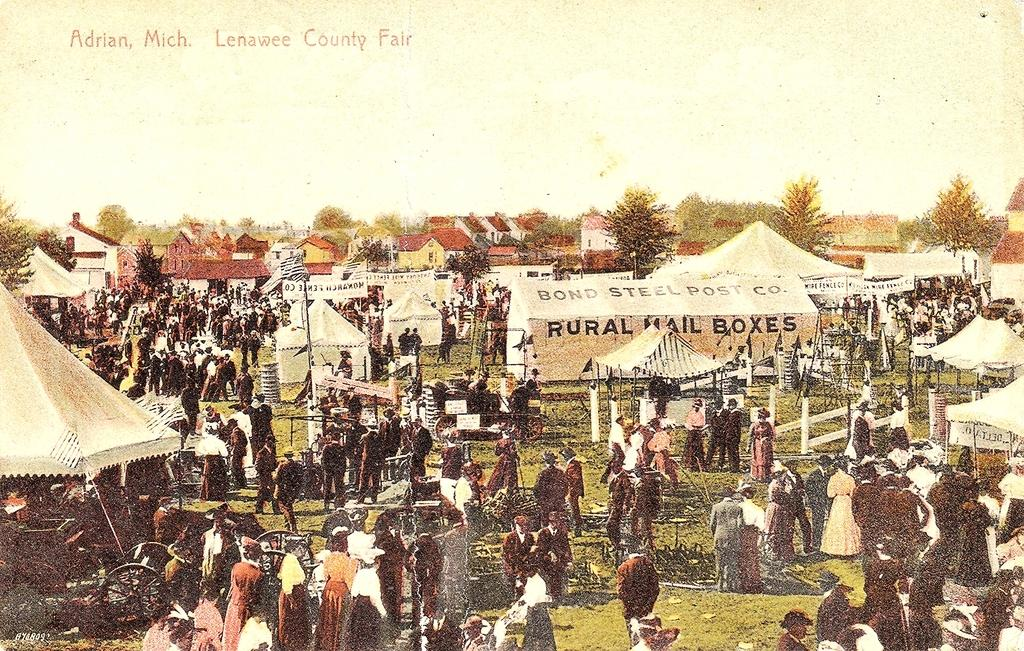<image>
Offer a succinct explanation of the picture presented. a picture that was taken of the lenawee county fair 